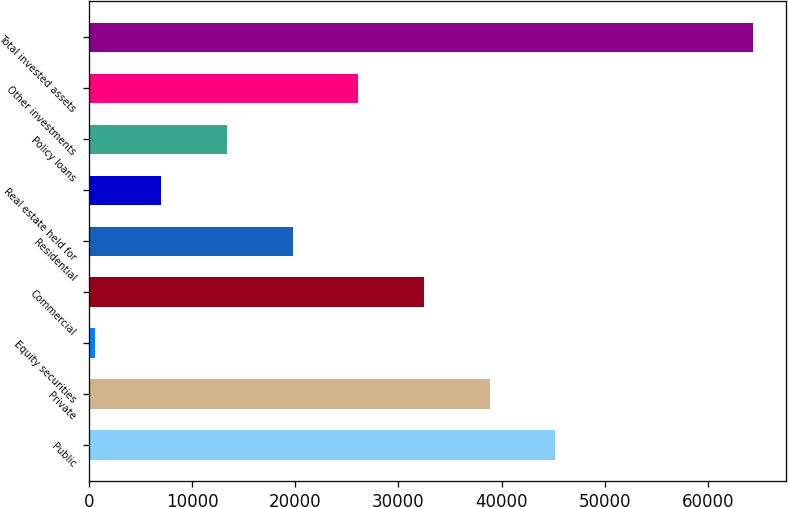<chart> <loc_0><loc_0><loc_500><loc_500><bar_chart><fcel>Public<fcel>Private<fcel>Equity securities<fcel>Commercial<fcel>Residential<fcel>Real estate held for<fcel>Policy loans<fcel>Other investments<fcel>Total invested assets<nl><fcel>45231.4<fcel>38853.5<fcel>586.2<fcel>32475.6<fcel>19719.8<fcel>6964.08<fcel>13342<fcel>26097.7<fcel>64365<nl></chart> 